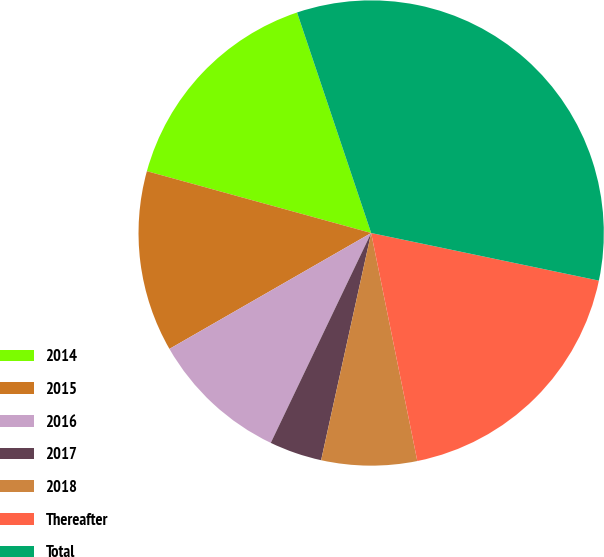Convert chart to OTSL. <chart><loc_0><loc_0><loc_500><loc_500><pie_chart><fcel>2014<fcel>2015<fcel>2016<fcel>2017<fcel>2018<fcel>Thereafter<fcel>Total<nl><fcel>15.56%<fcel>12.58%<fcel>9.6%<fcel>3.65%<fcel>6.63%<fcel>18.54%<fcel>33.44%<nl></chart> 